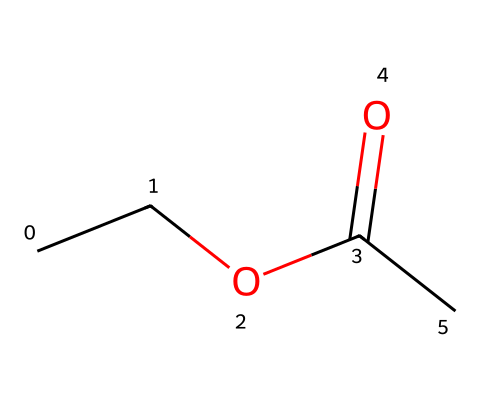What is the common name of the molecule represented? The molecule represented by the SMILES code is ethyl acetate. It is a simple ester formed from ethanol and acetic acid.
Answer: ethyl acetate How many carbon atoms are in ethyl acetate? In the structure, there are a total of four carbon atoms: two from the ethyl group (CC) and two from the acetate part (C(=O)C).
Answer: four What type of functional group is present in ethyl acetate? The SMILES representation shows a carbonyl group (C=O) directly bonded to an ether (C-O) structure, indicating it is an ester.
Answer: ester What is the total number of hydrogen atoms in ethyl acetate? Counting the hydrogen atoms, there are five attached to the ethyl group and one on the acetate part, totaling six hydrogen atoms.
Answer: six What is the type of bond between the carbon and oxygen in the carbonyl group? The carbon in the carbonyl group is double-bonded to oxygen, represented by the C(=O) notation in the SMILES, indicating a double bond.
Answer: double bond Why is ethyl acetate commonly used as a solvent? Ethyl acetate has a relatively low boiling point and good solvating properties due to its polar nature, making it effective for dissolving a variety of substances, particularly in nail polish removers.
Answer: low boiling point and good solvating properties 